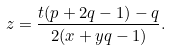<formula> <loc_0><loc_0><loc_500><loc_500>z = \frac { t ( p + 2 q - 1 ) - q } { 2 ( x + y q - 1 ) } .</formula> 